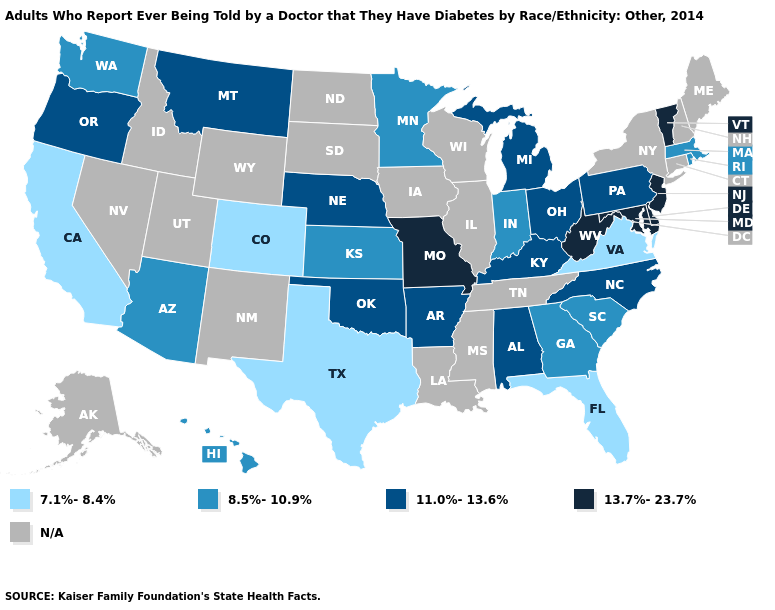Is the legend a continuous bar?
Be succinct. No. How many symbols are there in the legend?
Answer briefly. 5. What is the value of Maryland?
Quick response, please. 13.7%-23.7%. Among the states that border Oklahoma , which have the lowest value?
Concise answer only. Colorado, Texas. Name the states that have a value in the range N/A?
Answer briefly. Alaska, Connecticut, Idaho, Illinois, Iowa, Louisiana, Maine, Mississippi, Nevada, New Hampshire, New Mexico, New York, North Dakota, South Dakota, Tennessee, Utah, Wisconsin, Wyoming. What is the lowest value in states that border Kansas?
Be succinct. 7.1%-8.4%. What is the value of Texas?
Keep it brief. 7.1%-8.4%. Does Massachusetts have the lowest value in the Northeast?
Answer briefly. Yes. What is the highest value in the USA?
Give a very brief answer. 13.7%-23.7%. What is the value of Indiana?
Answer briefly. 8.5%-10.9%. Which states hav the highest value in the West?
Be succinct. Montana, Oregon. Name the states that have a value in the range 7.1%-8.4%?
Be succinct. California, Colorado, Florida, Texas, Virginia. Is the legend a continuous bar?
Short answer required. No. Which states have the lowest value in the South?
Be succinct. Florida, Texas, Virginia. What is the value of Mississippi?
Answer briefly. N/A. 